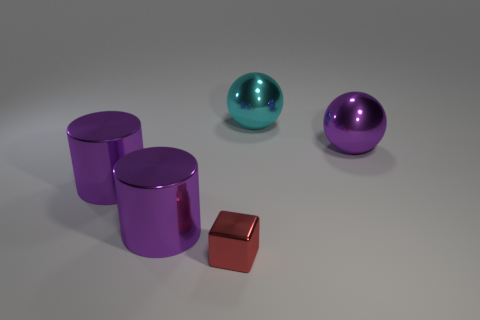What number of other things are there of the same material as the block
Ensure brevity in your answer.  4. There is a large metallic thing behind the big purple object that is on the right side of the metal block; what is its color?
Your answer should be very brief. Cyan. There is a thing that is on the right side of the large cyan metal sphere; is its color the same as the small object?
Ensure brevity in your answer.  No. Does the cyan sphere have the same size as the purple ball?
Your answer should be very brief. Yes. The cyan thing that is the same size as the purple sphere is what shape?
Ensure brevity in your answer.  Sphere. Is the size of the purple object to the right of the red object the same as the cyan shiny object?
Your answer should be compact. Yes. There is a ball that is on the left side of the big purple thing that is on the right side of the red metal object; is there a large thing right of it?
Make the answer very short. Yes. Are there any other things that have the same shape as the tiny red thing?
Your answer should be compact. No. Does the thing right of the cyan ball have the same color as the tiny metal thing that is in front of the large cyan thing?
Your answer should be compact. No. Is there a cyan ball?
Offer a terse response. Yes. 